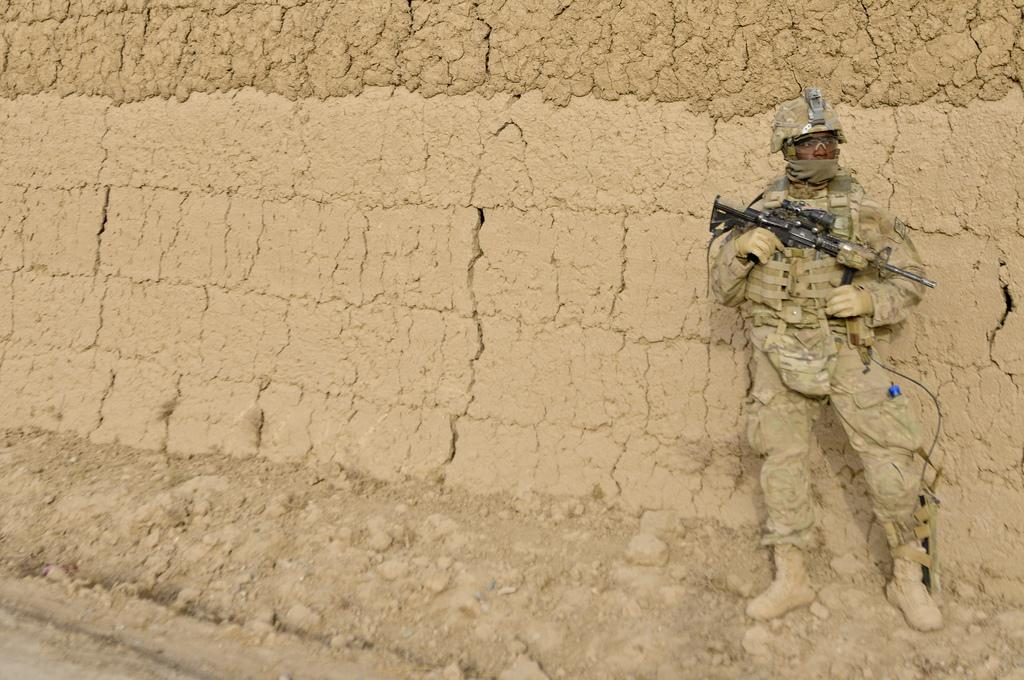What type of person is in the image? There is an army man in the image. What weapon does the army man have? The army man has a gun. What protective gear is the army man wearing? The army man is wearing a helmet. Where is the army man positioned in the image? The army man is standing on the ground. What type of barrier is present in the image? There is a sand wall in the image. Who is the army man looking at? The army man is looking at someone. What type of fruit is being used as a drum in the image? There is no fruit or drum present in the image. 